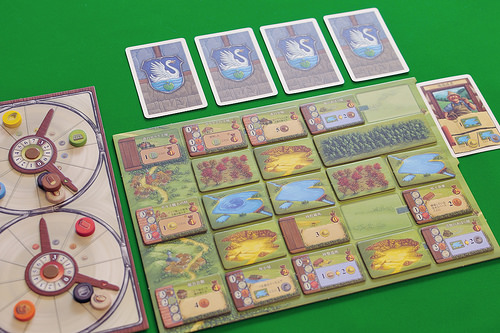<image>
Is there a card above the board? No. The card is not positioned above the board. The vertical arrangement shows a different relationship. 